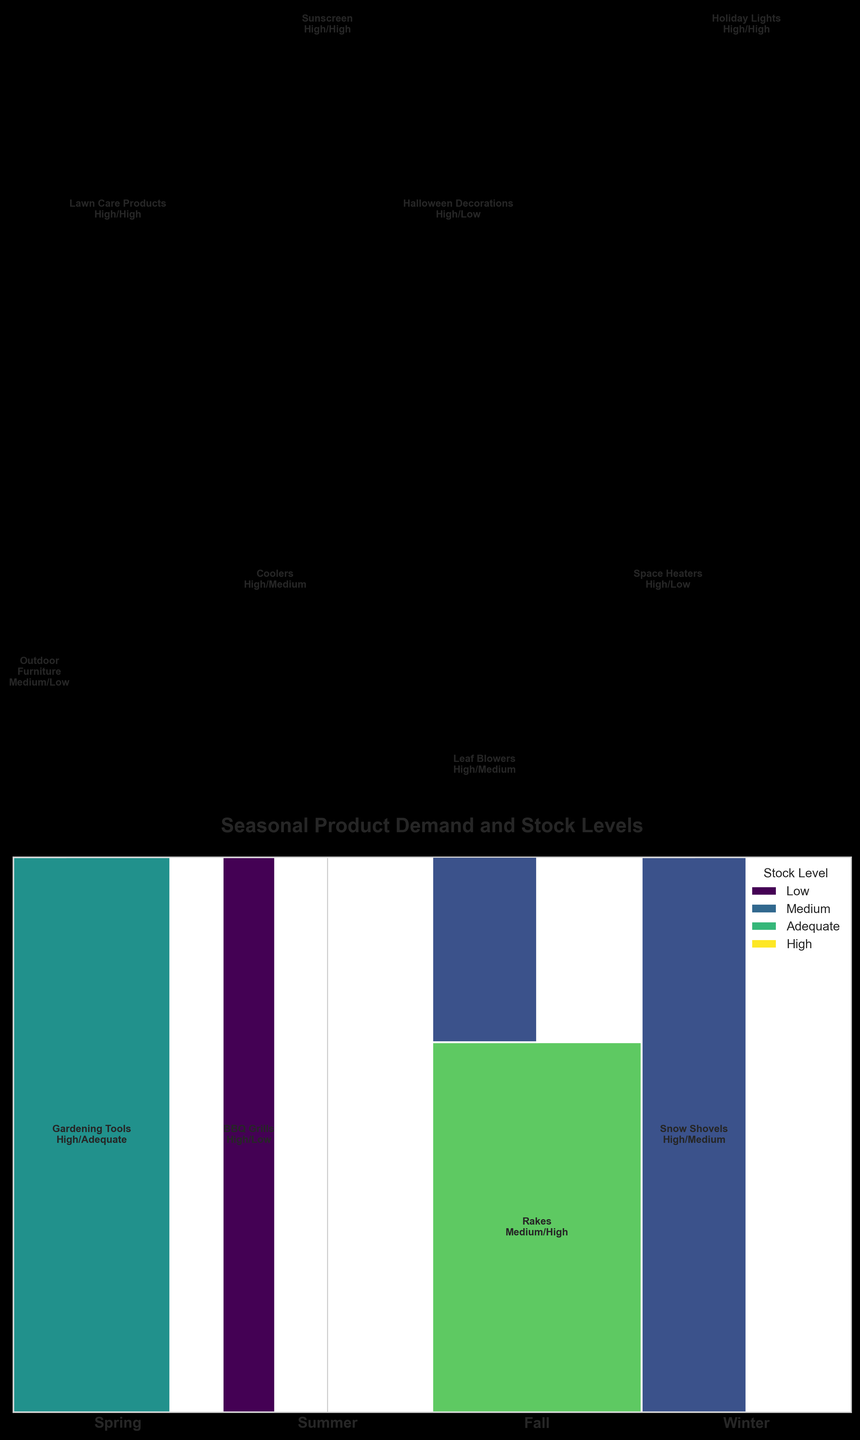What is the title of the mosaic plot? The title of a plot is typically found at the top and it provides a summary of what the plot is about. In this case, the title "Seasonal Product Demand and Stock Levels" indicates that the plot captures variations in demand and stock levels across different seasons and products.
Answer: "Seasonal Product Demand and Stock Levels" How many seasons are analyzed in the plot? To determine the number of seasons, count the distinct segments along the x-axis representing each season. This mosaic plot has a unique section for each season, visually separated.
Answer: 4 Which season has the product with the highest demand but the lowest stock level? To identify this, we need to check each season's "High" demand products and then compare their stock levels. The product "BBQ Grills" in Summer has a high demand and low stock level, making Summer the season we're looking for.
Answer: Summer Which product has adequate stock in the Spring? We need to find the rectangle corresponding to Spring and check the product labels. The product labeled with "Adequate" stock in the Spring is "Gardening Tools".
Answer: Gardening Tools How does the stock level of space heaters in Winter compare to the stock level of outdoor furniture in Spring? First, locate the segments for "Space Heaters" in Winter and "Outdoor Furniture" in Spring. Note their stock levels. Space heaters in Winter have "Low" stock, while outdoor furniture in Spring has "Low" stock as well. Both stock levels are the same.
Answer: Equal Which season has the lowest overall stock availability across all products? By adding up the stock levels (interpreted via width) for each season, we can compare them. Summer contains "Low" for BBQ Grills, "Medium" for Coolers, and "High" for Sunscreen, which collectively are generally low compared to other seasons.
Answer: Summer What is the combined demand level for Fall products that have high stock levels? Check each product in Fall and see their stock levels and corresponding demand. Both "Leaf Blowers" and "Rakes" have "High" stock levels. The demand levels are "High" and "Medium" respectively. The combined demand level is the count of those (2 products).
Answer: 2 products Compare the demand for Holiday Lights in Winter with gardening tools in Spring. Which is higher? Look for "Holiday Lights" in Winter and "Gardening Tools" in Spring. Both are labeled as having "High" demand. Therefore, neither is higher than the other.
Answer: Equal Which product in Fall has the most limited stock? In the Fall section, we need to identify the product with the smallest width rectangle (most limited stock). "Halloween Decorations" is labeled with "Low" stock, making it the most limited.
Answer: Halloween Decorations What proportion of Winter products have high demand? Out of the Winter products (Snow Shovels, Space Heaters, Holiday Lights), check their demand levels. All three products have "High" demand. The proportion is 3 out of 3.
Answer: 100% 